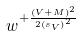<formula> <loc_0><loc_0><loc_500><loc_500>w ^ { + \frac { ( V + M ) ^ { 2 } } { 2 { ( s _ { V } ) } ^ { 2 } } }</formula> 